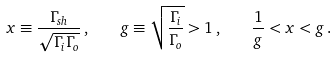Convert formula to latex. <formula><loc_0><loc_0><loc_500><loc_500>x \equiv \frac { \Gamma _ { s h } } { \sqrt { \Gamma _ { i } \Gamma _ { o } } } \, , \quad g \equiv \sqrt { \frac { \Gamma _ { i } } { \Gamma _ { o } } } > 1 \, , \quad \frac { 1 } { g } < x < g \, .</formula> 